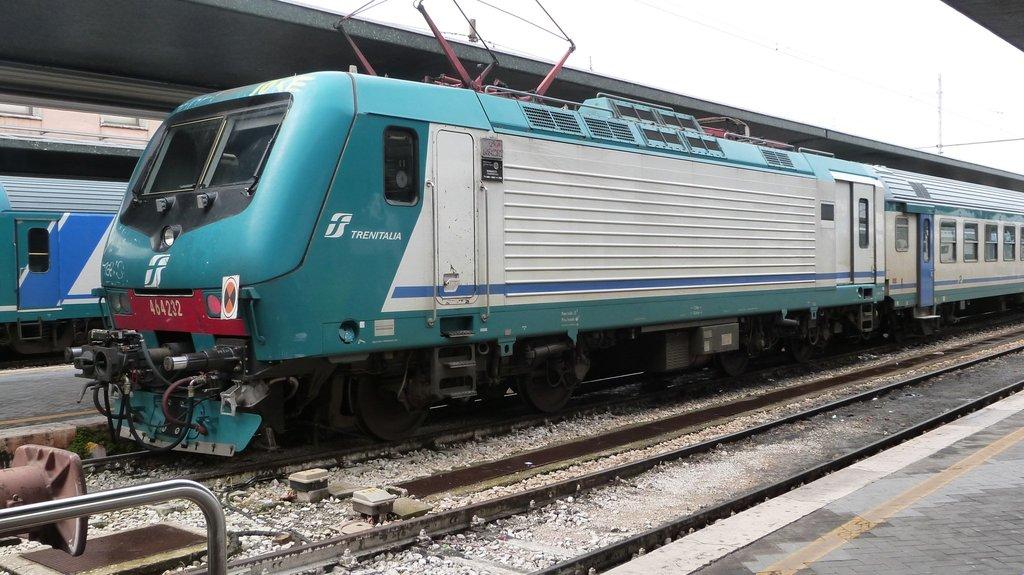What is the train company?
Your answer should be very brief. Trenitalia. What is the number of the train?
Your answer should be very brief. 464232. 